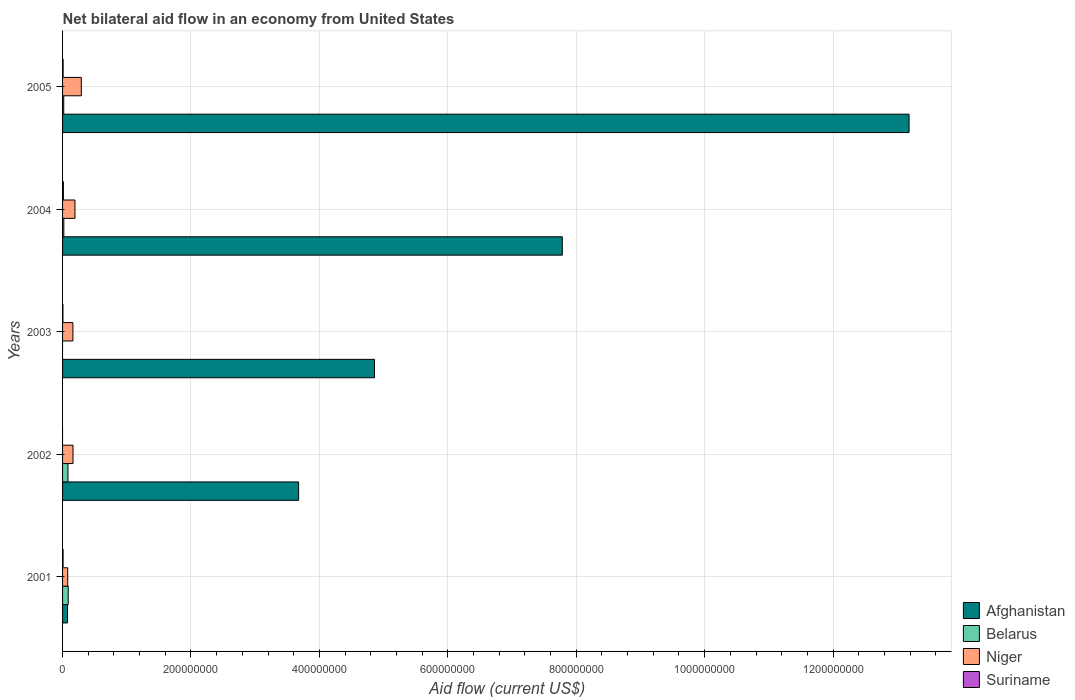How many different coloured bars are there?
Make the answer very short. 4. How many groups of bars are there?
Provide a short and direct response. 5. Are the number of bars on each tick of the Y-axis equal?
Give a very brief answer. No. How many bars are there on the 2nd tick from the top?
Your response must be concise. 4. In how many cases, is the number of bars for a given year not equal to the number of legend labels?
Your answer should be compact. 2. What is the net bilateral aid flow in Suriname in 2001?
Make the answer very short. 8.10e+05. Across all years, what is the maximum net bilateral aid flow in Belarus?
Give a very brief answer. 8.83e+06. In which year was the net bilateral aid flow in Afghanistan maximum?
Ensure brevity in your answer.  2005. What is the total net bilateral aid flow in Niger in the graph?
Make the answer very short. 8.89e+07. What is the difference between the net bilateral aid flow in Afghanistan in 2003 and that in 2004?
Give a very brief answer. -2.92e+08. What is the difference between the net bilateral aid flow in Suriname in 2001 and the net bilateral aid flow in Afghanistan in 2002?
Your response must be concise. -3.67e+08. What is the average net bilateral aid flow in Afghanistan per year?
Keep it short and to the point. 5.92e+08. In the year 2005, what is the difference between the net bilateral aid flow in Suriname and net bilateral aid flow in Belarus?
Keep it short and to the point. -9.50e+05. In how many years, is the net bilateral aid flow in Belarus greater than 640000000 US$?
Your answer should be very brief. 0. What is the ratio of the net bilateral aid flow in Suriname in 2004 to that in 2005?
Ensure brevity in your answer.  1.52. Is the net bilateral aid flow in Niger in 2002 less than that in 2003?
Your answer should be compact. No. What is the difference between the highest and the second highest net bilateral aid flow in Niger?
Your response must be concise. 9.88e+06. What is the difference between the highest and the lowest net bilateral aid flow in Suriname?
Keep it short and to the point. 1.31e+06. In how many years, is the net bilateral aid flow in Suriname greater than the average net bilateral aid flow in Suriname taken over all years?
Make the answer very short. 3. Is the sum of the net bilateral aid flow in Suriname in 2001 and 2004 greater than the maximum net bilateral aid flow in Afghanistan across all years?
Your answer should be very brief. No. Is it the case that in every year, the sum of the net bilateral aid flow in Niger and net bilateral aid flow in Afghanistan is greater than the sum of net bilateral aid flow in Belarus and net bilateral aid flow in Suriname?
Ensure brevity in your answer.  No. How many bars are there?
Your answer should be very brief. 18. How many years are there in the graph?
Provide a short and direct response. 5. What is the difference between two consecutive major ticks on the X-axis?
Provide a short and direct response. 2.00e+08. Are the values on the major ticks of X-axis written in scientific E-notation?
Make the answer very short. No. Does the graph contain any zero values?
Your answer should be compact. Yes. Where does the legend appear in the graph?
Your answer should be very brief. Bottom right. What is the title of the graph?
Make the answer very short. Net bilateral aid flow in an economy from United States. What is the label or title of the X-axis?
Provide a short and direct response. Aid flow (current US$). What is the Aid flow (current US$) in Afghanistan in 2001?
Give a very brief answer. 7.70e+06. What is the Aid flow (current US$) of Belarus in 2001?
Provide a succinct answer. 8.83e+06. What is the Aid flow (current US$) in Niger in 2001?
Provide a succinct answer. 8.02e+06. What is the Aid flow (current US$) in Suriname in 2001?
Your answer should be compact. 8.10e+05. What is the Aid flow (current US$) in Afghanistan in 2002?
Ensure brevity in your answer.  3.68e+08. What is the Aid flow (current US$) in Belarus in 2002?
Offer a very short reply. 8.42e+06. What is the Aid flow (current US$) in Niger in 2002?
Provide a succinct answer. 1.63e+07. What is the Aid flow (current US$) of Suriname in 2002?
Provide a succinct answer. 0. What is the Aid flow (current US$) of Afghanistan in 2003?
Your answer should be compact. 4.86e+08. What is the Aid flow (current US$) in Niger in 2003?
Ensure brevity in your answer.  1.61e+07. What is the Aid flow (current US$) of Suriname in 2003?
Keep it short and to the point. 5.70e+05. What is the Aid flow (current US$) in Afghanistan in 2004?
Keep it short and to the point. 7.78e+08. What is the Aid flow (current US$) in Belarus in 2004?
Ensure brevity in your answer.  1.96e+06. What is the Aid flow (current US$) of Niger in 2004?
Give a very brief answer. 1.93e+07. What is the Aid flow (current US$) of Suriname in 2004?
Ensure brevity in your answer.  1.31e+06. What is the Aid flow (current US$) in Afghanistan in 2005?
Ensure brevity in your answer.  1.32e+09. What is the Aid flow (current US$) of Belarus in 2005?
Provide a short and direct response. 1.81e+06. What is the Aid flow (current US$) in Niger in 2005?
Ensure brevity in your answer.  2.92e+07. What is the Aid flow (current US$) in Suriname in 2005?
Offer a very short reply. 8.60e+05. Across all years, what is the maximum Aid flow (current US$) in Afghanistan?
Your answer should be compact. 1.32e+09. Across all years, what is the maximum Aid flow (current US$) of Belarus?
Provide a short and direct response. 8.83e+06. Across all years, what is the maximum Aid flow (current US$) of Niger?
Give a very brief answer. 2.92e+07. Across all years, what is the maximum Aid flow (current US$) in Suriname?
Your answer should be very brief. 1.31e+06. Across all years, what is the minimum Aid flow (current US$) in Afghanistan?
Make the answer very short. 7.70e+06. Across all years, what is the minimum Aid flow (current US$) of Niger?
Make the answer very short. 8.02e+06. Across all years, what is the minimum Aid flow (current US$) in Suriname?
Provide a short and direct response. 0. What is the total Aid flow (current US$) of Afghanistan in the graph?
Ensure brevity in your answer.  2.96e+09. What is the total Aid flow (current US$) in Belarus in the graph?
Your answer should be very brief. 2.10e+07. What is the total Aid flow (current US$) in Niger in the graph?
Provide a succinct answer. 8.89e+07. What is the total Aid flow (current US$) in Suriname in the graph?
Give a very brief answer. 3.55e+06. What is the difference between the Aid flow (current US$) of Afghanistan in 2001 and that in 2002?
Provide a succinct answer. -3.60e+08. What is the difference between the Aid flow (current US$) in Niger in 2001 and that in 2002?
Your response must be concise. -8.25e+06. What is the difference between the Aid flow (current US$) of Afghanistan in 2001 and that in 2003?
Keep it short and to the point. -4.78e+08. What is the difference between the Aid flow (current US$) of Niger in 2001 and that in 2003?
Your answer should be very brief. -8.11e+06. What is the difference between the Aid flow (current US$) in Afghanistan in 2001 and that in 2004?
Keep it short and to the point. -7.71e+08. What is the difference between the Aid flow (current US$) in Belarus in 2001 and that in 2004?
Offer a terse response. 6.87e+06. What is the difference between the Aid flow (current US$) in Niger in 2001 and that in 2004?
Make the answer very short. -1.13e+07. What is the difference between the Aid flow (current US$) in Suriname in 2001 and that in 2004?
Your answer should be very brief. -5.00e+05. What is the difference between the Aid flow (current US$) of Afghanistan in 2001 and that in 2005?
Make the answer very short. -1.31e+09. What is the difference between the Aid flow (current US$) of Belarus in 2001 and that in 2005?
Keep it short and to the point. 7.02e+06. What is the difference between the Aid flow (current US$) in Niger in 2001 and that in 2005?
Provide a succinct answer. -2.12e+07. What is the difference between the Aid flow (current US$) in Suriname in 2001 and that in 2005?
Your answer should be compact. -5.00e+04. What is the difference between the Aid flow (current US$) in Afghanistan in 2002 and that in 2003?
Your answer should be very brief. -1.18e+08. What is the difference between the Aid flow (current US$) of Niger in 2002 and that in 2003?
Offer a terse response. 1.40e+05. What is the difference between the Aid flow (current US$) of Afghanistan in 2002 and that in 2004?
Offer a terse response. -4.11e+08. What is the difference between the Aid flow (current US$) in Belarus in 2002 and that in 2004?
Provide a succinct answer. 6.46e+06. What is the difference between the Aid flow (current US$) of Niger in 2002 and that in 2004?
Offer a very short reply. -3.05e+06. What is the difference between the Aid flow (current US$) of Afghanistan in 2002 and that in 2005?
Provide a short and direct response. -9.51e+08. What is the difference between the Aid flow (current US$) in Belarus in 2002 and that in 2005?
Give a very brief answer. 6.61e+06. What is the difference between the Aid flow (current US$) of Niger in 2002 and that in 2005?
Keep it short and to the point. -1.29e+07. What is the difference between the Aid flow (current US$) in Afghanistan in 2003 and that in 2004?
Provide a short and direct response. -2.92e+08. What is the difference between the Aid flow (current US$) of Niger in 2003 and that in 2004?
Make the answer very short. -3.19e+06. What is the difference between the Aid flow (current US$) of Suriname in 2003 and that in 2004?
Offer a terse response. -7.40e+05. What is the difference between the Aid flow (current US$) of Afghanistan in 2003 and that in 2005?
Your answer should be compact. -8.33e+08. What is the difference between the Aid flow (current US$) in Niger in 2003 and that in 2005?
Provide a succinct answer. -1.31e+07. What is the difference between the Aid flow (current US$) in Afghanistan in 2004 and that in 2005?
Your answer should be very brief. -5.40e+08. What is the difference between the Aid flow (current US$) in Niger in 2004 and that in 2005?
Give a very brief answer. -9.88e+06. What is the difference between the Aid flow (current US$) in Suriname in 2004 and that in 2005?
Provide a succinct answer. 4.50e+05. What is the difference between the Aid flow (current US$) of Afghanistan in 2001 and the Aid flow (current US$) of Belarus in 2002?
Provide a short and direct response. -7.20e+05. What is the difference between the Aid flow (current US$) of Afghanistan in 2001 and the Aid flow (current US$) of Niger in 2002?
Provide a succinct answer. -8.57e+06. What is the difference between the Aid flow (current US$) of Belarus in 2001 and the Aid flow (current US$) of Niger in 2002?
Keep it short and to the point. -7.44e+06. What is the difference between the Aid flow (current US$) in Afghanistan in 2001 and the Aid flow (current US$) in Niger in 2003?
Your response must be concise. -8.43e+06. What is the difference between the Aid flow (current US$) in Afghanistan in 2001 and the Aid flow (current US$) in Suriname in 2003?
Your response must be concise. 7.13e+06. What is the difference between the Aid flow (current US$) of Belarus in 2001 and the Aid flow (current US$) of Niger in 2003?
Your answer should be compact. -7.30e+06. What is the difference between the Aid flow (current US$) of Belarus in 2001 and the Aid flow (current US$) of Suriname in 2003?
Offer a very short reply. 8.26e+06. What is the difference between the Aid flow (current US$) of Niger in 2001 and the Aid flow (current US$) of Suriname in 2003?
Give a very brief answer. 7.45e+06. What is the difference between the Aid flow (current US$) in Afghanistan in 2001 and the Aid flow (current US$) in Belarus in 2004?
Offer a terse response. 5.74e+06. What is the difference between the Aid flow (current US$) in Afghanistan in 2001 and the Aid flow (current US$) in Niger in 2004?
Offer a very short reply. -1.16e+07. What is the difference between the Aid flow (current US$) in Afghanistan in 2001 and the Aid flow (current US$) in Suriname in 2004?
Ensure brevity in your answer.  6.39e+06. What is the difference between the Aid flow (current US$) in Belarus in 2001 and the Aid flow (current US$) in Niger in 2004?
Your response must be concise. -1.05e+07. What is the difference between the Aid flow (current US$) of Belarus in 2001 and the Aid flow (current US$) of Suriname in 2004?
Your answer should be compact. 7.52e+06. What is the difference between the Aid flow (current US$) in Niger in 2001 and the Aid flow (current US$) in Suriname in 2004?
Provide a succinct answer. 6.71e+06. What is the difference between the Aid flow (current US$) of Afghanistan in 2001 and the Aid flow (current US$) of Belarus in 2005?
Your response must be concise. 5.89e+06. What is the difference between the Aid flow (current US$) of Afghanistan in 2001 and the Aid flow (current US$) of Niger in 2005?
Your response must be concise. -2.15e+07. What is the difference between the Aid flow (current US$) in Afghanistan in 2001 and the Aid flow (current US$) in Suriname in 2005?
Make the answer very short. 6.84e+06. What is the difference between the Aid flow (current US$) of Belarus in 2001 and the Aid flow (current US$) of Niger in 2005?
Your response must be concise. -2.04e+07. What is the difference between the Aid flow (current US$) in Belarus in 2001 and the Aid flow (current US$) in Suriname in 2005?
Give a very brief answer. 7.97e+06. What is the difference between the Aid flow (current US$) in Niger in 2001 and the Aid flow (current US$) in Suriname in 2005?
Keep it short and to the point. 7.16e+06. What is the difference between the Aid flow (current US$) in Afghanistan in 2002 and the Aid flow (current US$) in Niger in 2003?
Give a very brief answer. 3.51e+08. What is the difference between the Aid flow (current US$) of Afghanistan in 2002 and the Aid flow (current US$) of Suriname in 2003?
Your answer should be compact. 3.67e+08. What is the difference between the Aid flow (current US$) of Belarus in 2002 and the Aid flow (current US$) of Niger in 2003?
Provide a succinct answer. -7.71e+06. What is the difference between the Aid flow (current US$) of Belarus in 2002 and the Aid flow (current US$) of Suriname in 2003?
Keep it short and to the point. 7.85e+06. What is the difference between the Aid flow (current US$) in Niger in 2002 and the Aid flow (current US$) in Suriname in 2003?
Ensure brevity in your answer.  1.57e+07. What is the difference between the Aid flow (current US$) in Afghanistan in 2002 and the Aid flow (current US$) in Belarus in 2004?
Your response must be concise. 3.66e+08. What is the difference between the Aid flow (current US$) of Afghanistan in 2002 and the Aid flow (current US$) of Niger in 2004?
Ensure brevity in your answer.  3.48e+08. What is the difference between the Aid flow (current US$) in Afghanistan in 2002 and the Aid flow (current US$) in Suriname in 2004?
Keep it short and to the point. 3.66e+08. What is the difference between the Aid flow (current US$) in Belarus in 2002 and the Aid flow (current US$) in Niger in 2004?
Your answer should be compact. -1.09e+07. What is the difference between the Aid flow (current US$) of Belarus in 2002 and the Aid flow (current US$) of Suriname in 2004?
Give a very brief answer. 7.11e+06. What is the difference between the Aid flow (current US$) in Niger in 2002 and the Aid flow (current US$) in Suriname in 2004?
Give a very brief answer. 1.50e+07. What is the difference between the Aid flow (current US$) of Afghanistan in 2002 and the Aid flow (current US$) of Belarus in 2005?
Provide a short and direct response. 3.66e+08. What is the difference between the Aid flow (current US$) of Afghanistan in 2002 and the Aid flow (current US$) of Niger in 2005?
Your response must be concise. 3.38e+08. What is the difference between the Aid flow (current US$) in Afghanistan in 2002 and the Aid flow (current US$) in Suriname in 2005?
Keep it short and to the point. 3.67e+08. What is the difference between the Aid flow (current US$) in Belarus in 2002 and the Aid flow (current US$) in Niger in 2005?
Provide a short and direct response. -2.08e+07. What is the difference between the Aid flow (current US$) of Belarus in 2002 and the Aid flow (current US$) of Suriname in 2005?
Your response must be concise. 7.56e+06. What is the difference between the Aid flow (current US$) in Niger in 2002 and the Aid flow (current US$) in Suriname in 2005?
Give a very brief answer. 1.54e+07. What is the difference between the Aid flow (current US$) of Afghanistan in 2003 and the Aid flow (current US$) of Belarus in 2004?
Offer a terse response. 4.84e+08. What is the difference between the Aid flow (current US$) in Afghanistan in 2003 and the Aid flow (current US$) in Niger in 2004?
Keep it short and to the point. 4.66e+08. What is the difference between the Aid flow (current US$) in Afghanistan in 2003 and the Aid flow (current US$) in Suriname in 2004?
Provide a short and direct response. 4.84e+08. What is the difference between the Aid flow (current US$) in Niger in 2003 and the Aid flow (current US$) in Suriname in 2004?
Ensure brevity in your answer.  1.48e+07. What is the difference between the Aid flow (current US$) in Afghanistan in 2003 and the Aid flow (current US$) in Belarus in 2005?
Offer a very short reply. 4.84e+08. What is the difference between the Aid flow (current US$) of Afghanistan in 2003 and the Aid flow (current US$) of Niger in 2005?
Your response must be concise. 4.57e+08. What is the difference between the Aid flow (current US$) of Afghanistan in 2003 and the Aid flow (current US$) of Suriname in 2005?
Ensure brevity in your answer.  4.85e+08. What is the difference between the Aid flow (current US$) in Niger in 2003 and the Aid flow (current US$) in Suriname in 2005?
Your answer should be very brief. 1.53e+07. What is the difference between the Aid flow (current US$) in Afghanistan in 2004 and the Aid flow (current US$) in Belarus in 2005?
Ensure brevity in your answer.  7.76e+08. What is the difference between the Aid flow (current US$) in Afghanistan in 2004 and the Aid flow (current US$) in Niger in 2005?
Keep it short and to the point. 7.49e+08. What is the difference between the Aid flow (current US$) in Afghanistan in 2004 and the Aid flow (current US$) in Suriname in 2005?
Your answer should be very brief. 7.77e+08. What is the difference between the Aid flow (current US$) in Belarus in 2004 and the Aid flow (current US$) in Niger in 2005?
Keep it short and to the point. -2.72e+07. What is the difference between the Aid flow (current US$) in Belarus in 2004 and the Aid flow (current US$) in Suriname in 2005?
Make the answer very short. 1.10e+06. What is the difference between the Aid flow (current US$) in Niger in 2004 and the Aid flow (current US$) in Suriname in 2005?
Make the answer very short. 1.85e+07. What is the average Aid flow (current US$) in Afghanistan per year?
Your answer should be very brief. 5.92e+08. What is the average Aid flow (current US$) of Belarus per year?
Ensure brevity in your answer.  4.20e+06. What is the average Aid flow (current US$) in Niger per year?
Give a very brief answer. 1.78e+07. What is the average Aid flow (current US$) of Suriname per year?
Give a very brief answer. 7.10e+05. In the year 2001, what is the difference between the Aid flow (current US$) in Afghanistan and Aid flow (current US$) in Belarus?
Ensure brevity in your answer.  -1.13e+06. In the year 2001, what is the difference between the Aid flow (current US$) of Afghanistan and Aid flow (current US$) of Niger?
Provide a succinct answer. -3.20e+05. In the year 2001, what is the difference between the Aid flow (current US$) of Afghanistan and Aid flow (current US$) of Suriname?
Provide a short and direct response. 6.89e+06. In the year 2001, what is the difference between the Aid flow (current US$) of Belarus and Aid flow (current US$) of Niger?
Give a very brief answer. 8.10e+05. In the year 2001, what is the difference between the Aid flow (current US$) in Belarus and Aid flow (current US$) in Suriname?
Your answer should be very brief. 8.02e+06. In the year 2001, what is the difference between the Aid flow (current US$) of Niger and Aid flow (current US$) of Suriname?
Offer a terse response. 7.21e+06. In the year 2002, what is the difference between the Aid flow (current US$) of Afghanistan and Aid flow (current US$) of Belarus?
Your response must be concise. 3.59e+08. In the year 2002, what is the difference between the Aid flow (current US$) in Afghanistan and Aid flow (current US$) in Niger?
Your answer should be very brief. 3.51e+08. In the year 2002, what is the difference between the Aid flow (current US$) in Belarus and Aid flow (current US$) in Niger?
Keep it short and to the point. -7.85e+06. In the year 2003, what is the difference between the Aid flow (current US$) in Afghanistan and Aid flow (current US$) in Niger?
Your answer should be compact. 4.70e+08. In the year 2003, what is the difference between the Aid flow (current US$) in Afghanistan and Aid flow (current US$) in Suriname?
Offer a terse response. 4.85e+08. In the year 2003, what is the difference between the Aid flow (current US$) in Niger and Aid flow (current US$) in Suriname?
Offer a very short reply. 1.56e+07. In the year 2004, what is the difference between the Aid flow (current US$) in Afghanistan and Aid flow (current US$) in Belarus?
Your response must be concise. 7.76e+08. In the year 2004, what is the difference between the Aid flow (current US$) of Afghanistan and Aid flow (current US$) of Niger?
Provide a short and direct response. 7.59e+08. In the year 2004, what is the difference between the Aid flow (current US$) of Afghanistan and Aid flow (current US$) of Suriname?
Offer a terse response. 7.77e+08. In the year 2004, what is the difference between the Aid flow (current US$) in Belarus and Aid flow (current US$) in Niger?
Give a very brief answer. -1.74e+07. In the year 2004, what is the difference between the Aid flow (current US$) of Belarus and Aid flow (current US$) of Suriname?
Provide a short and direct response. 6.50e+05. In the year 2004, what is the difference between the Aid flow (current US$) in Niger and Aid flow (current US$) in Suriname?
Give a very brief answer. 1.80e+07. In the year 2005, what is the difference between the Aid flow (current US$) of Afghanistan and Aid flow (current US$) of Belarus?
Your answer should be compact. 1.32e+09. In the year 2005, what is the difference between the Aid flow (current US$) in Afghanistan and Aid flow (current US$) in Niger?
Ensure brevity in your answer.  1.29e+09. In the year 2005, what is the difference between the Aid flow (current US$) in Afghanistan and Aid flow (current US$) in Suriname?
Make the answer very short. 1.32e+09. In the year 2005, what is the difference between the Aid flow (current US$) of Belarus and Aid flow (current US$) of Niger?
Your answer should be compact. -2.74e+07. In the year 2005, what is the difference between the Aid flow (current US$) in Belarus and Aid flow (current US$) in Suriname?
Provide a short and direct response. 9.50e+05. In the year 2005, what is the difference between the Aid flow (current US$) in Niger and Aid flow (current US$) in Suriname?
Your response must be concise. 2.83e+07. What is the ratio of the Aid flow (current US$) in Afghanistan in 2001 to that in 2002?
Your response must be concise. 0.02. What is the ratio of the Aid flow (current US$) in Belarus in 2001 to that in 2002?
Provide a succinct answer. 1.05. What is the ratio of the Aid flow (current US$) of Niger in 2001 to that in 2002?
Provide a short and direct response. 0.49. What is the ratio of the Aid flow (current US$) in Afghanistan in 2001 to that in 2003?
Make the answer very short. 0.02. What is the ratio of the Aid flow (current US$) in Niger in 2001 to that in 2003?
Keep it short and to the point. 0.5. What is the ratio of the Aid flow (current US$) of Suriname in 2001 to that in 2003?
Offer a terse response. 1.42. What is the ratio of the Aid flow (current US$) in Afghanistan in 2001 to that in 2004?
Keep it short and to the point. 0.01. What is the ratio of the Aid flow (current US$) in Belarus in 2001 to that in 2004?
Your answer should be very brief. 4.51. What is the ratio of the Aid flow (current US$) of Niger in 2001 to that in 2004?
Keep it short and to the point. 0.42. What is the ratio of the Aid flow (current US$) in Suriname in 2001 to that in 2004?
Keep it short and to the point. 0.62. What is the ratio of the Aid flow (current US$) of Afghanistan in 2001 to that in 2005?
Make the answer very short. 0.01. What is the ratio of the Aid flow (current US$) in Belarus in 2001 to that in 2005?
Your answer should be compact. 4.88. What is the ratio of the Aid flow (current US$) of Niger in 2001 to that in 2005?
Ensure brevity in your answer.  0.27. What is the ratio of the Aid flow (current US$) in Suriname in 2001 to that in 2005?
Offer a terse response. 0.94. What is the ratio of the Aid flow (current US$) in Afghanistan in 2002 to that in 2003?
Your answer should be very brief. 0.76. What is the ratio of the Aid flow (current US$) of Niger in 2002 to that in 2003?
Your answer should be very brief. 1.01. What is the ratio of the Aid flow (current US$) in Afghanistan in 2002 to that in 2004?
Give a very brief answer. 0.47. What is the ratio of the Aid flow (current US$) in Belarus in 2002 to that in 2004?
Keep it short and to the point. 4.3. What is the ratio of the Aid flow (current US$) in Niger in 2002 to that in 2004?
Ensure brevity in your answer.  0.84. What is the ratio of the Aid flow (current US$) of Afghanistan in 2002 to that in 2005?
Your response must be concise. 0.28. What is the ratio of the Aid flow (current US$) of Belarus in 2002 to that in 2005?
Offer a terse response. 4.65. What is the ratio of the Aid flow (current US$) of Niger in 2002 to that in 2005?
Your answer should be very brief. 0.56. What is the ratio of the Aid flow (current US$) in Afghanistan in 2003 to that in 2004?
Make the answer very short. 0.62. What is the ratio of the Aid flow (current US$) of Niger in 2003 to that in 2004?
Provide a short and direct response. 0.83. What is the ratio of the Aid flow (current US$) of Suriname in 2003 to that in 2004?
Provide a short and direct response. 0.44. What is the ratio of the Aid flow (current US$) in Afghanistan in 2003 to that in 2005?
Keep it short and to the point. 0.37. What is the ratio of the Aid flow (current US$) of Niger in 2003 to that in 2005?
Your answer should be compact. 0.55. What is the ratio of the Aid flow (current US$) in Suriname in 2003 to that in 2005?
Ensure brevity in your answer.  0.66. What is the ratio of the Aid flow (current US$) of Afghanistan in 2004 to that in 2005?
Keep it short and to the point. 0.59. What is the ratio of the Aid flow (current US$) in Belarus in 2004 to that in 2005?
Provide a short and direct response. 1.08. What is the ratio of the Aid flow (current US$) in Niger in 2004 to that in 2005?
Provide a succinct answer. 0.66. What is the ratio of the Aid flow (current US$) of Suriname in 2004 to that in 2005?
Provide a succinct answer. 1.52. What is the difference between the highest and the second highest Aid flow (current US$) in Afghanistan?
Your response must be concise. 5.40e+08. What is the difference between the highest and the second highest Aid flow (current US$) of Niger?
Give a very brief answer. 9.88e+06. What is the difference between the highest and the lowest Aid flow (current US$) in Afghanistan?
Your response must be concise. 1.31e+09. What is the difference between the highest and the lowest Aid flow (current US$) of Belarus?
Give a very brief answer. 8.83e+06. What is the difference between the highest and the lowest Aid flow (current US$) in Niger?
Give a very brief answer. 2.12e+07. What is the difference between the highest and the lowest Aid flow (current US$) in Suriname?
Your answer should be compact. 1.31e+06. 